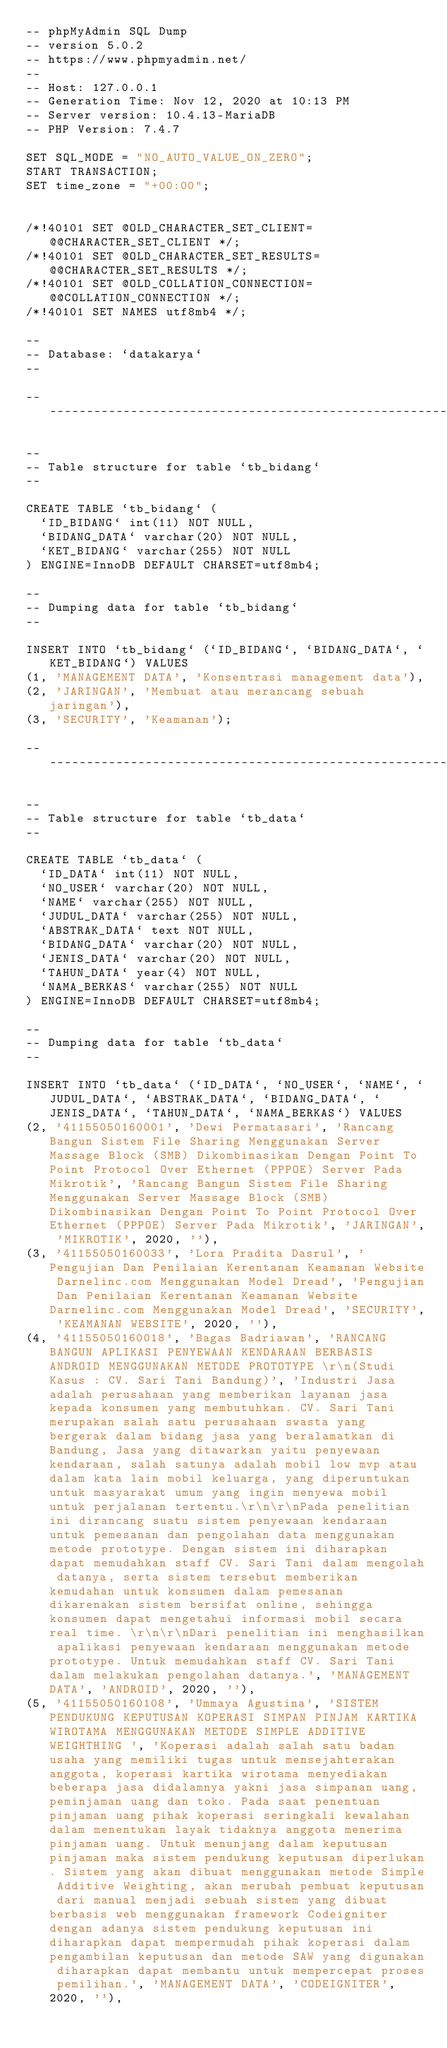Convert code to text. <code><loc_0><loc_0><loc_500><loc_500><_SQL_>-- phpMyAdmin SQL Dump
-- version 5.0.2
-- https://www.phpmyadmin.net/
--
-- Host: 127.0.0.1
-- Generation Time: Nov 12, 2020 at 10:13 PM
-- Server version: 10.4.13-MariaDB
-- PHP Version: 7.4.7

SET SQL_MODE = "NO_AUTO_VALUE_ON_ZERO";
START TRANSACTION;
SET time_zone = "+00:00";


/*!40101 SET @OLD_CHARACTER_SET_CLIENT=@@CHARACTER_SET_CLIENT */;
/*!40101 SET @OLD_CHARACTER_SET_RESULTS=@@CHARACTER_SET_RESULTS */;
/*!40101 SET @OLD_COLLATION_CONNECTION=@@COLLATION_CONNECTION */;
/*!40101 SET NAMES utf8mb4 */;

--
-- Database: `datakarya`
--

-- --------------------------------------------------------

--
-- Table structure for table `tb_bidang`
--

CREATE TABLE `tb_bidang` (
  `ID_BIDANG` int(11) NOT NULL,
  `BIDANG_DATA` varchar(20) NOT NULL,
  `KET_BIDANG` varchar(255) NOT NULL
) ENGINE=InnoDB DEFAULT CHARSET=utf8mb4;

--
-- Dumping data for table `tb_bidang`
--

INSERT INTO `tb_bidang` (`ID_BIDANG`, `BIDANG_DATA`, `KET_BIDANG`) VALUES
(1, 'MANAGEMENT DATA', 'Konsentrasi management data'),
(2, 'JARINGAN', 'Membuat atau merancang sebuah jaringan'),
(3, 'SECURITY', 'Keamanan');

-- --------------------------------------------------------

--
-- Table structure for table `tb_data`
--

CREATE TABLE `tb_data` (
  `ID_DATA` int(11) NOT NULL,
  `NO_USER` varchar(20) NOT NULL,
  `NAME` varchar(255) NOT NULL,
  `JUDUL_DATA` varchar(255) NOT NULL,
  `ABSTRAK_DATA` text NOT NULL,
  `BIDANG_DATA` varchar(20) NOT NULL,
  `JENIS_DATA` varchar(20) NOT NULL,
  `TAHUN_DATA` year(4) NOT NULL,
  `NAMA_BERKAS` varchar(255) NOT NULL
) ENGINE=InnoDB DEFAULT CHARSET=utf8mb4;

--
-- Dumping data for table `tb_data`
--

INSERT INTO `tb_data` (`ID_DATA`, `NO_USER`, `NAME`, `JUDUL_DATA`, `ABSTRAK_DATA`, `BIDANG_DATA`, `JENIS_DATA`, `TAHUN_DATA`, `NAMA_BERKAS`) VALUES
(2, '41155050160001', 'Dewi Permatasari', 'Rancang Bangun Sistem File Sharing Menggunakan Server Massage Block (SMB) Dikombinasikan Dengan Point To Point Protocol Over Ethernet (PPPOE) Server Pada Mikrotik', 'Rancang Bangun Sistem File Sharing Menggunakan Server Massage Block (SMB) Dikombinasikan Dengan Point To Point Protocol Over Ethernet (PPPOE) Server Pada Mikrotik', 'JARINGAN', 'MIKROTIK', 2020, ''),
(3, '41155050160033', 'Lora Pradita Dasrul', 'Pengujian Dan Penilaian Kerentanan Keamanan Website Darnelinc.com Menggunakan Model Dread', 'Pengujian Dan Penilaian Kerentanan Keamanan Website Darnelinc.com Menggunakan Model Dread', 'SECURITY', 'KEAMANAN WEBSITE', 2020, ''),
(4, '41155050160018', 'Bagas Badriawan', 'RANCANG BANGUN APLIKASI PENYEWAAN KENDARAAN BERBASIS ANDROID MENGGUNAKAN METODE PROTOTYPE \r\n(Studi Kasus : CV. Sari Tani Bandung)', 'Industri Jasa adalah perusahaan yang memberikan layanan jasa kepada konsumen yang membutuhkan. CV. Sari Tani merupakan salah satu perusahaan swasta yang bergerak dalam bidang jasa yang beralamatkan di Bandung, Jasa yang ditawarkan yaitu penyewaan kendaraan, salah satunya adalah mobil low mvp atau dalam kata lain mobil keluarga, yang diperuntukan untuk masyarakat umum yang ingin menyewa mobil untuk perjalanan tertentu.\r\n\r\nPada penelitian ini dirancang suatu sistem penyewaan kendaraan untuk pemesanan dan pengolahan data menggunakan metode prototype. Dengan sistem ini diharapkan dapat memudahkan staff CV. Sari Tani dalam mengolah datanya, serta sistem tersebut memberikan kemudahan untuk konsumen dalam pemesanan dikarenakan sistem bersifat online, sehingga konsumen dapat mengetahui informasi mobil secara real time. \r\n\r\nDari penelitian ini menghasilkan apalikasi penyewaan kendaraan menggunakan metode prototype. Untuk memudahkan staff CV. Sari Tani dalam melakukan pengolahan datanya.', 'MANAGEMENT DATA', 'ANDROID', 2020, ''),
(5, '41155050160108', 'Ummaya Agustina', 'SISTEM PENDUKUNG KEPUTUSAN KOPERASI SIMPAN PINJAM KARTIKA WIROTAMA MENGGUNAKAN METODE SIMPLE ADDITIVE WEIGHTHING ', 'Koperasi adalah salah satu badan usaha yang memiliki tugas untuk mensejahterakan anggota, koperasi kartika wirotama menyediakan beberapa jasa didalamnya yakni jasa simpanan uang, peminjaman uang dan toko. Pada saat penentuan pinjaman uang pihak koperasi seringkali kewalahan dalam menentukan layak tidaknya anggota menerima pinjaman uang. Untuk menunjang dalam keputusan pinjaman maka sistem pendukung keputusan diperlukan. Sistem yang akan dibuat menggunakan metode Simple Additive Weighting, akan merubah pembuat keputusan dari manual menjadi sebuah sistem yang dibuat berbasis web menggunakan framework Codeigniter dengan adanya sistem pendukung keputusan ini diharapkan dapat mempermudah pihak koperasi dalam pengambilan keputusan dan metode SAW yang digunakan diharapkan dapat membantu untuk mempercepat proses pemilihan.', 'MANAGEMENT DATA', 'CODEIGNITER', 2020, ''),</code> 